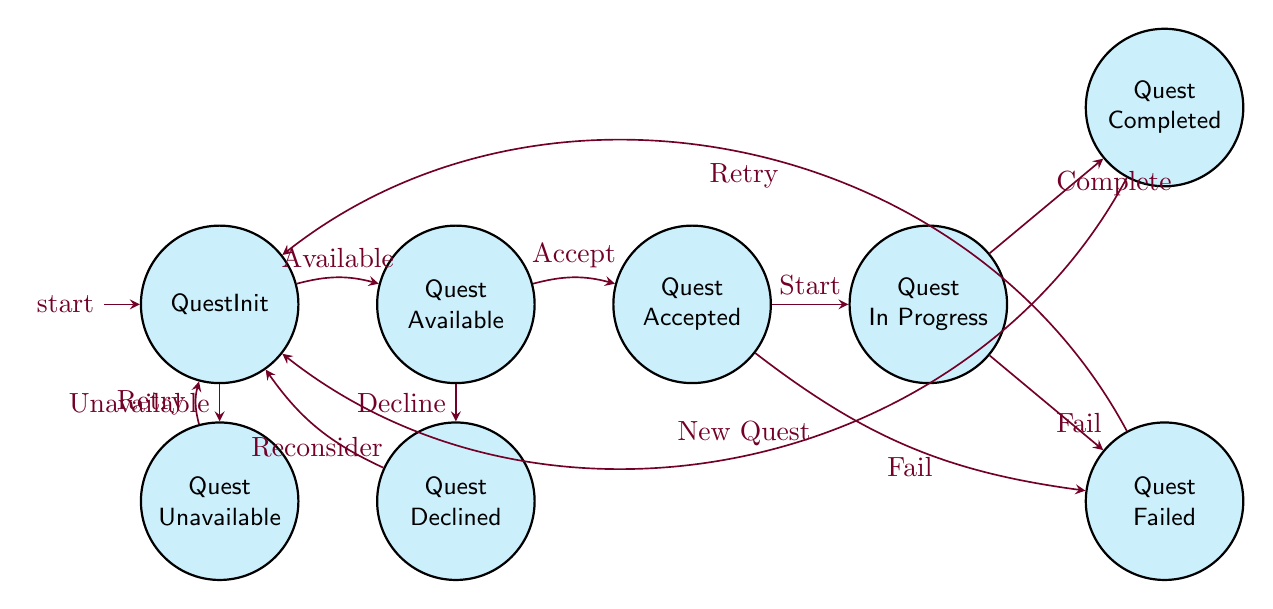What is the initial state of the quest system? The initial state is represented by the node labeled "QuestInit." This is the starting point of the quest activation checks within the finite state machine.
Answer: QuestInit How many transitions does the "QuestAccepted" state have? The "QuestAccepted" state has two possible transitions: one leading to "QuestInProgress" and another to "QuestFailed." Therefore, the total number of transitions from this state is two.
Answer: 2 What state does the player enter after accepting a quest? Accepting a quest transitions the player to the "QuestInProgress" state. This state signifies that the player has taken on the quest and is currently working on it.
Answer: QuestInProgress Which state leads back to "QuestInit" when a quest is completed? Upon completion of a quest, the player transitions from the "QuestCompleted" state back to the "QuestInit" state. This movement signifies the end of that quest cycle and readiness for new quests.
Answer: QuestInit What happens if a player fails a quest? If the player fails a quest, they will transition to the "QuestFailed" state. This state indicates that the player did not complete the quest successfully and will also lead back to "QuestInit" to potentially start a different quest.
Answer: QuestFailed How many total states are in the finite state machine diagram? The diagram consists of a total of eight states: "QuestInit," "QuestAvailable," "QuestUnavailable," "QuestAccepted," "QuestDeclined," "QuestInProgress," "QuestCompleted," and "QuestFailed." Counting each of these gives a total of eight states.
Answer: 8 What action allows a player to retry a quest after failing? The option to retry a quest after failure is represented by the action labeled "Retry," which takes the player from the "QuestFailed" state back to "QuestInit." This prompts them to potentially start a new quest or attempt the previous one again.
Answer: Retry Which state can the player return to after declining a quest? If a player declines a quest, they return to the "QuestInit" state. This transition indicates they are no longer pursuing that specific quest and can look for other available quests.
Answer: QuestInit What is the state that can be reached after the quest is in progress? When a quest is in progress, the player can either complete the quest, transitioning to "QuestCompleted," or they can fail the quest, transitioning to "QuestFailed."
Answer: QuestCompleted or QuestFailed 